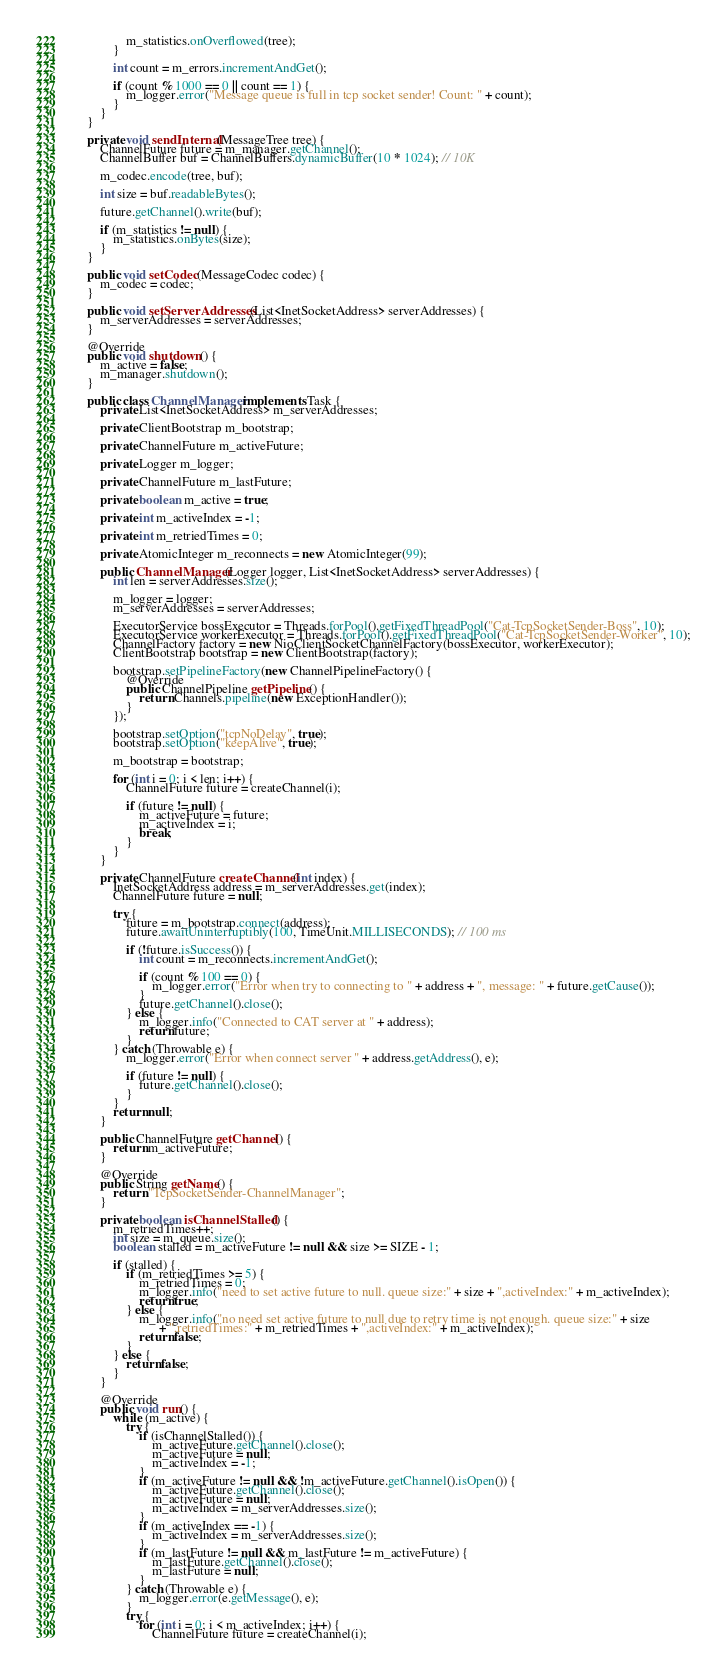Convert code to text. <code><loc_0><loc_0><loc_500><loc_500><_Java_>				m_statistics.onOverflowed(tree);
			}

			int count = m_errors.incrementAndGet();

			if (count % 1000 == 0 || count == 1) {
				m_logger.error("Message queue is full in tcp socket sender! Count: " + count);
			}
		}
	}

	private void sendInternal(MessageTree tree) {
		ChannelFuture future = m_manager.getChannel();
		ChannelBuffer buf = ChannelBuffers.dynamicBuffer(10 * 1024); // 10K

		m_codec.encode(tree, buf);

		int size = buf.readableBytes();

		future.getChannel().write(buf);

		if (m_statistics != null) {
			m_statistics.onBytes(size);
		}
	}

	public void setCodec(MessageCodec codec) {
		m_codec = codec;
	}

	public void setServerAddresses(List<InetSocketAddress> serverAddresses) {
		m_serverAddresses = serverAddresses;
	}

	@Override
	public void shutdown() {
		m_active = false;
		m_manager.shutdown();
	}

	public class ChannelManager implements Task {
		private List<InetSocketAddress> m_serverAddresses;

		private ClientBootstrap m_bootstrap;

		private ChannelFuture m_activeFuture;

		private Logger m_logger;

		private ChannelFuture m_lastFuture;

		private boolean m_active = true;

		private int m_activeIndex = -1;

		private int m_retriedTimes = 0;

		private AtomicInteger m_reconnects = new AtomicInteger(99);

		public ChannelManager(Logger logger, List<InetSocketAddress> serverAddresses) {
			int len = serverAddresses.size();

			m_logger = logger;
			m_serverAddresses = serverAddresses;

			ExecutorService bossExecutor = Threads.forPool().getFixedThreadPool("Cat-TcpSocketSender-Boss", 10);
			ExecutorService workerExecutor = Threads.forPool().getFixedThreadPool("Cat-TcpSocketSender-Worker", 10);
			ChannelFactory factory = new NioClientSocketChannelFactory(bossExecutor, workerExecutor);
			ClientBootstrap bootstrap = new ClientBootstrap(factory);

			bootstrap.setPipelineFactory(new ChannelPipelineFactory() {
				@Override
				public ChannelPipeline getPipeline() {
					return Channels.pipeline(new ExceptionHandler());
				}
			});

			bootstrap.setOption("tcpNoDelay", true);
			bootstrap.setOption("keepAlive", true);

			m_bootstrap = bootstrap;

			for (int i = 0; i < len; i++) {
				ChannelFuture future = createChannel(i);

				if (future != null) {
					m_activeFuture = future;
					m_activeIndex = i;
					break;
				}
			}
		}

		private ChannelFuture createChannel(int index) {
			InetSocketAddress address = m_serverAddresses.get(index);
			ChannelFuture future = null;

			try {
				future = m_bootstrap.connect(address);
				future.awaitUninterruptibly(100, TimeUnit.MILLISECONDS); // 100 ms

				if (!future.isSuccess()) {
					int count = m_reconnects.incrementAndGet();

					if (count % 100 == 0) {
						m_logger.error("Error when try to connecting to " + address + ", message: " + future.getCause());
					}
					future.getChannel().close();
				} else {
					m_logger.info("Connected to CAT server at " + address);
					return future;
				}
			} catch (Throwable e) {
				m_logger.error("Error when connect server " + address.getAddress(), e);

				if (future != null) {
					future.getChannel().close();
				}
			}
			return null;
		}

		public ChannelFuture getChannel() {
			return m_activeFuture;
		}

		@Override
		public String getName() {
			return "TcpSocketSender-ChannelManager";
		}

		private boolean isChannelStalled() {
			m_retriedTimes++;
			int size = m_queue.size();
			boolean stalled = m_activeFuture != null && size >= SIZE - 1;

			if (stalled) {
				if (m_retriedTimes >= 5) {
					m_retriedTimes = 0;
					m_logger.info("need to set active future to null. queue size:" + size + ",activeIndex:" + m_activeIndex);
					return true;
				} else {
					m_logger.info("no need set active future to null due to retry time is not enough. queue size:" + size
					      + ",retriedTimes:" + m_retriedTimes + ",activeIndex:" + m_activeIndex);
					return false;
				}
			} else {
				return false;
			}
		}

		@Override
		public void run() {
			while (m_active) {
				try {
					if (isChannelStalled()) {
						m_activeFuture.getChannel().close();
						m_activeFuture = null;
						m_activeIndex = -1;
					}
					if (m_activeFuture != null && !m_activeFuture.getChannel().isOpen()) {
						m_activeFuture.getChannel().close();
						m_activeFuture = null;
						m_activeIndex = m_serverAddresses.size();
					}
					if (m_activeIndex == -1) {
						m_activeIndex = m_serverAddresses.size();
					}
					if (m_lastFuture != null && m_lastFuture != m_activeFuture) {
						m_lastFuture.getChannel().close();
						m_lastFuture = null;
					}
				} catch (Throwable e) {
					m_logger.error(e.getMessage(), e);
				}
				try {
					for (int i = 0; i < m_activeIndex; i++) {
						ChannelFuture future = createChannel(i);
</code> 